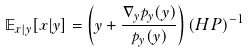Convert formula to latex. <formula><loc_0><loc_0><loc_500><loc_500>\mathbb { E } _ { x | y } { [ x | y ] } = \left ( { y } + \frac { \nabla _ { y } p _ { y } ( { y } ) } { p _ { y } ( { y } ) } \right ) ( H P ) ^ { - 1 }</formula> 